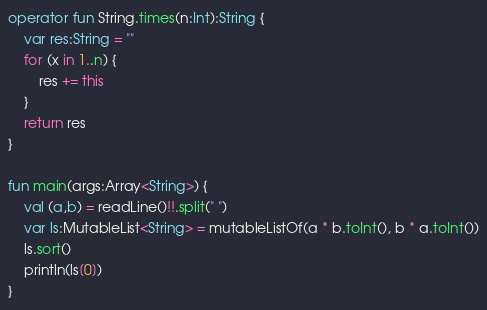Convert code to text. <code><loc_0><loc_0><loc_500><loc_500><_Kotlin_>operator fun String.times(n:Int):String {
    var res:String = ""
    for (x in 1..n) {
        res += this
    }
    return res
}

fun main(args:Array<String>) {
    val (a,b) = readLine()!!.split(" ")
    var ls:MutableList<String> = mutableListOf(a * b.toInt(), b * a.toInt())
    ls.sort()
    println(ls[0])
}</code> 